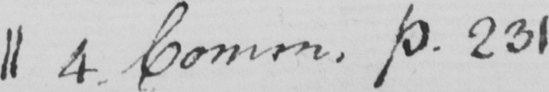What text is written in this handwritten line? 4 . Comm . p.231 